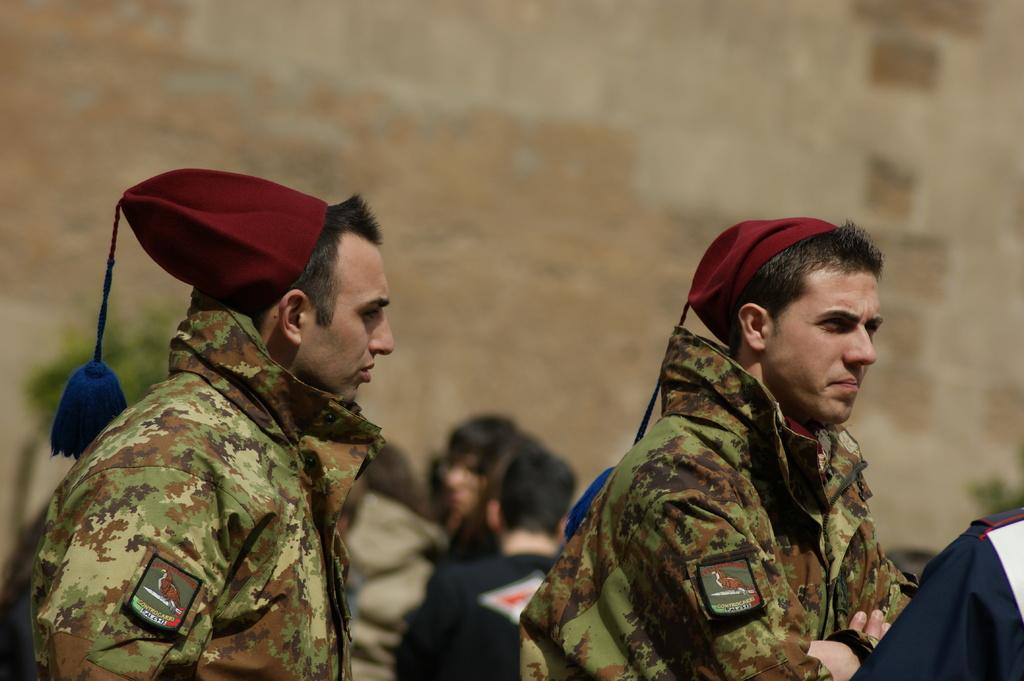How many people are in the image? There are two men in the image. What are the men wearing on their heads? Both men are wearing caps. What can be seen behind the men in the image? There are objects visible in the background of the image. How would you describe the appearance of the background? The background is blurry. What type of land can be seen in the image? There is no land visible in the image; it is focused on the two men and the background. 